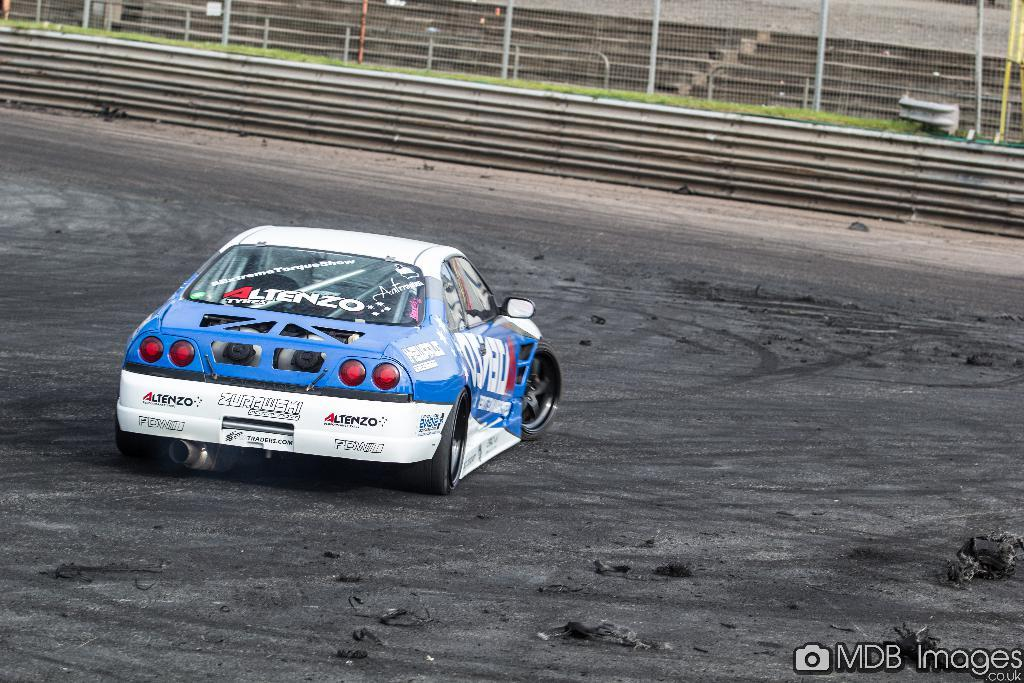What type of vehicle is in the image? There is a sports car in the image. What is the sports car doing in the image? The sports car is moving on an empty land. What is surrounding the empty land? There is fencing around the land. What architectural feature can be seen behind the fencing? There are steps behind the fencing. Where is the sock being washed in the image? There is no sock or washing activity present in the image. 